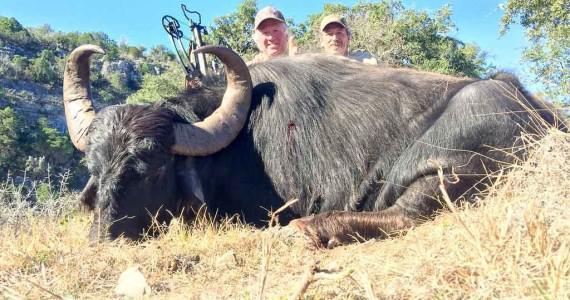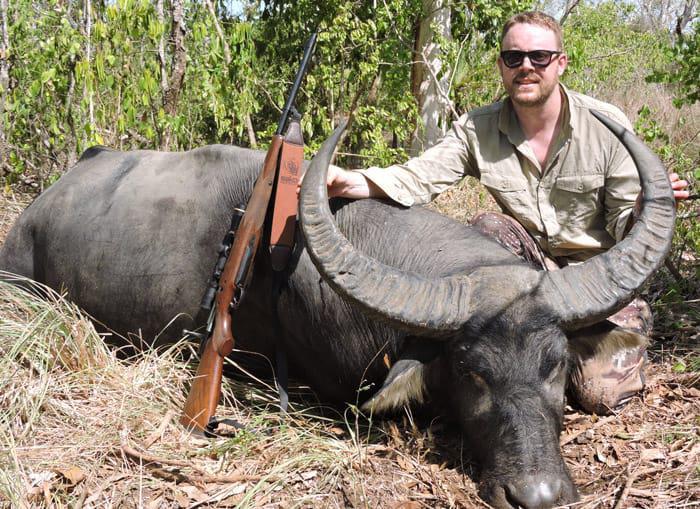The first image is the image on the left, the second image is the image on the right. Given the left and right images, does the statement "Two hunters pose with a weapon behind a downed water buffalo in the left image." hold true? Answer yes or no. Yes. The first image is the image on the left, the second image is the image on the right. Considering the images on both sides, is "In one of the images, two men can be seen posing next to a deceased water buffalo." valid? Answer yes or no. Yes. 